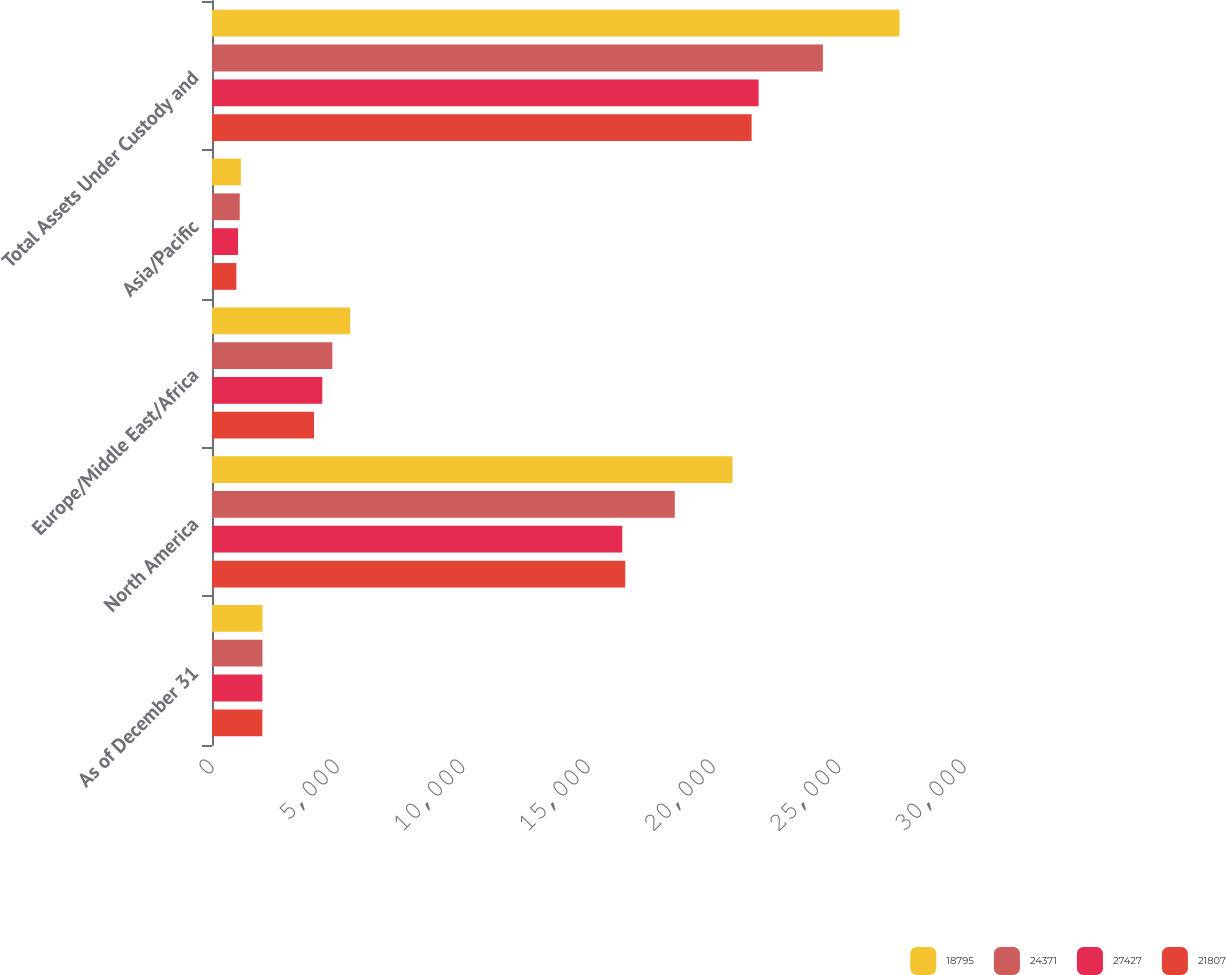<chart> <loc_0><loc_0><loc_500><loc_500><stacked_bar_chart><ecel><fcel>As of December 31<fcel>North America<fcel>Europe/Middle East/Africa<fcel>Asia/Pacific<fcel>Total Assets Under Custody and<nl><fcel>18795<fcel>2013<fcel>20764<fcel>5511<fcel>1152<fcel>27427<nl><fcel>24371<fcel>2012<fcel>18463<fcel>4801<fcel>1107<fcel>24371<nl><fcel>27427<fcel>2011<fcel>16368<fcel>4400<fcel>1039<fcel>21807<nl><fcel>21807<fcel>2010<fcel>16486<fcel>4069<fcel>972<fcel>21527<nl></chart> 